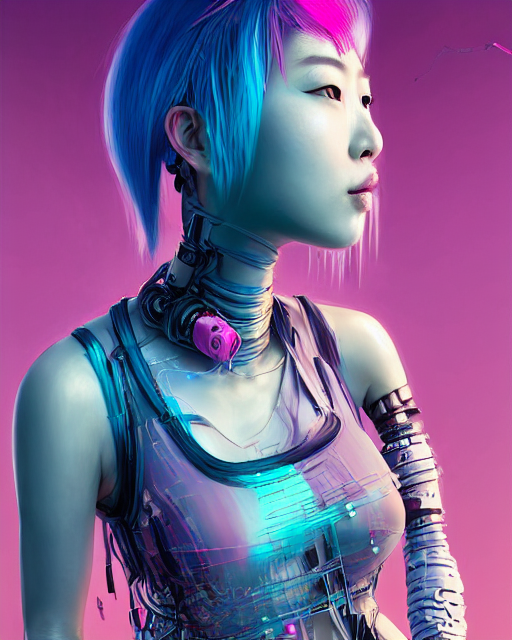Is there distortion in the robot's clothes? Yes, there does appear to be a distortion in the robot's clothes. It can be observed as a sense of irregularity and visual warping within the clothing's fabric, which might be due to the rendering process or a deliberate design choice to emphasise the robotic form beneath. 